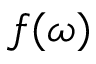<formula> <loc_0><loc_0><loc_500><loc_500>f ( \omega )</formula> 